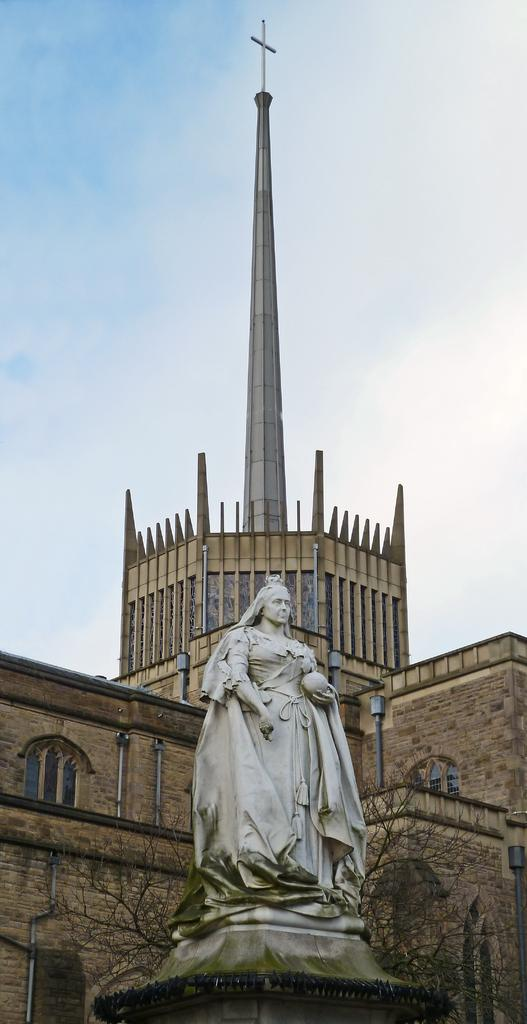What is the main subject in the image? There is a statue in the image. Where is the statue located in relation to other objects? The statue is in front of a building. What can be seen at the top of the image? Sky is visible at the top of the image. What type of cork can be seen on the statue's head in the image? There is no cork present on the statue's head in the image. How many leaves are attached to the statue in the image? There are no leaves present on the statue in the image. 